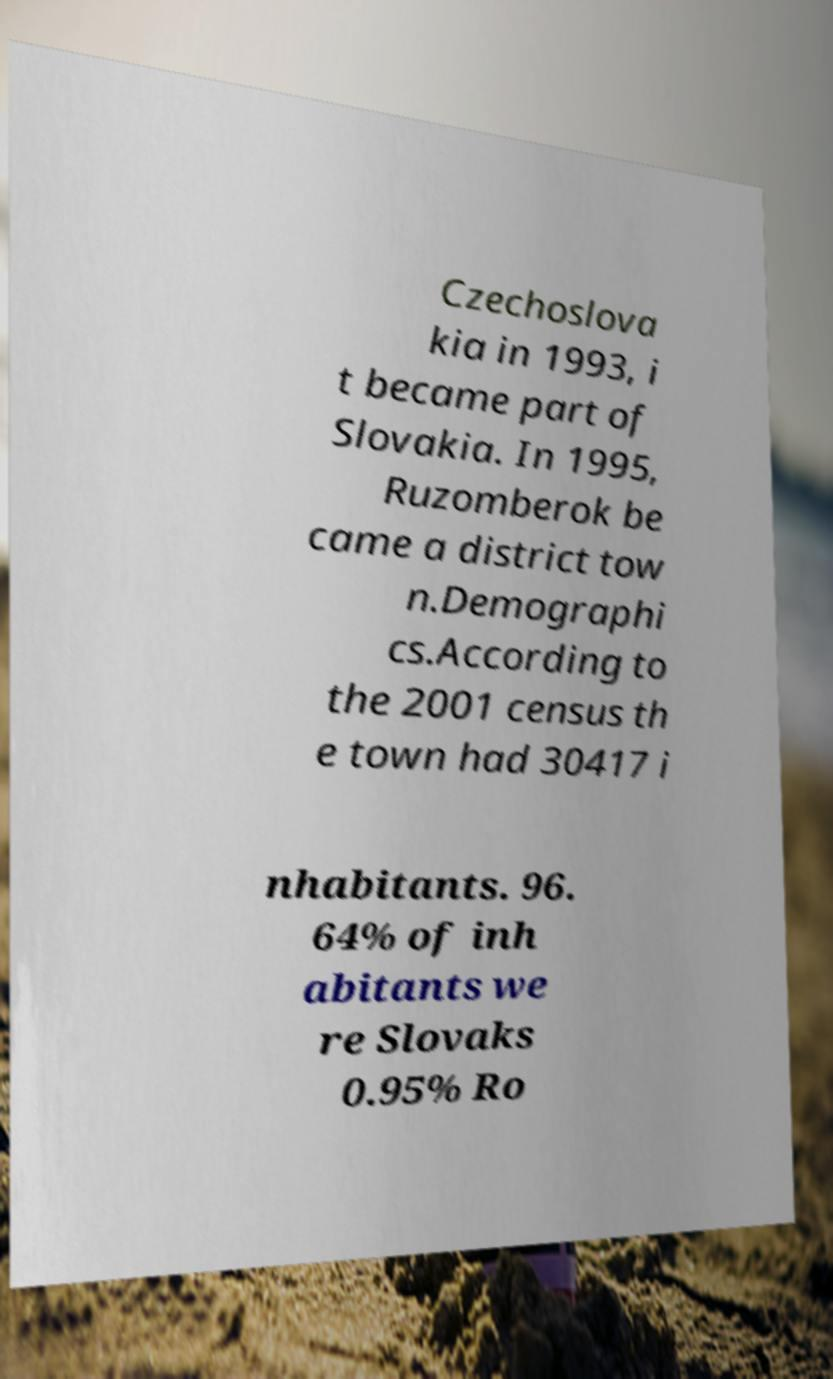What messages or text are displayed in this image? I need them in a readable, typed format. Czechoslova kia in 1993, i t became part of Slovakia. In 1995, Ruzomberok be came a district tow n.Demographi cs.According to the 2001 census th e town had 30417 i nhabitants. 96. 64% of inh abitants we re Slovaks 0.95% Ro 